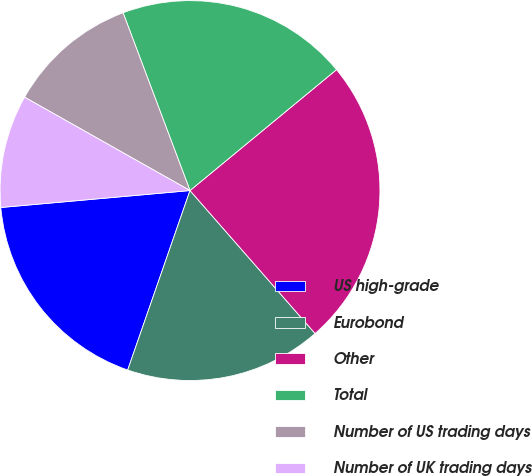<chart> <loc_0><loc_0><loc_500><loc_500><pie_chart><fcel>US high-grade<fcel>Eurobond<fcel>Other<fcel>Total<fcel>Number of US trading days<fcel>Number of UK trading days<nl><fcel>18.26%<fcel>16.76%<fcel>24.54%<fcel>19.75%<fcel>11.09%<fcel>9.6%<nl></chart> 